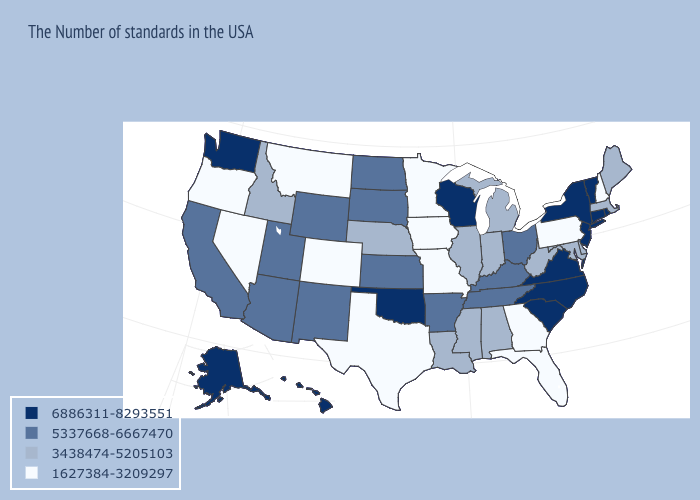Which states hav the highest value in the Northeast?
Answer briefly. Rhode Island, Vermont, Connecticut, New York, New Jersey. What is the value of Massachusetts?
Keep it brief. 3438474-5205103. Does Vermont have the highest value in the USA?
Give a very brief answer. Yes. Does Missouri have a lower value than Kentucky?
Keep it brief. Yes. What is the value of Missouri?
Keep it brief. 1627384-3209297. What is the highest value in states that border Ohio?
Keep it brief. 5337668-6667470. Among the states that border Connecticut , does New York have the lowest value?
Quick response, please. No. Does Indiana have a lower value than Mississippi?
Write a very short answer. No. What is the value of Indiana?
Short answer required. 3438474-5205103. Among the states that border Pennsylvania , which have the highest value?
Quick response, please. New York, New Jersey. What is the value of North Carolina?
Be succinct. 6886311-8293551. Does the map have missing data?
Be succinct. No. What is the highest value in the USA?
Give a very brief answer. 6886311-8293551. What is the value of Georgia?
Give a very brief answer. 1627384-3209297. What is the highest value in states that border Louisiana?
Be succinct. 5337668-6667470. 